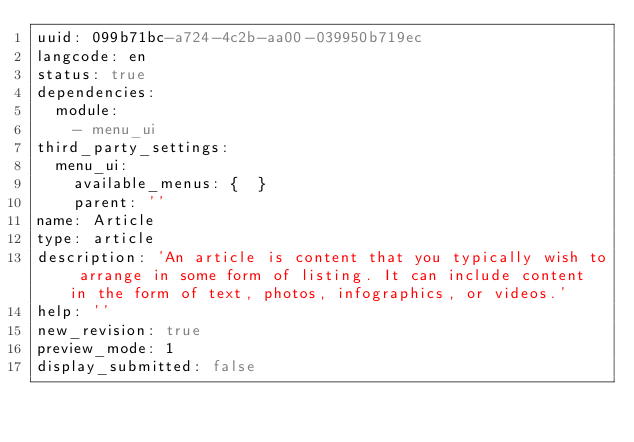Convert code to text. <code><loc_0><loc_0><loc_500><loc_500><_YAML_>uuid: 099b71bc-a724-4c2b-aa00-039950b719ec
langcode: en
status: true
dependencies:
  module:
    - menu_ui
third_party_settings:
  menu_ui:
    available_menus: {  }
    parent: ''
name: Article
type: article
description: 'An article is content that you typically wish to arrange in some form of listing. It can include content in the form of text, photos, infographics, or videos.'
help: ''
new_revision: true
preview_mode: 1
display_submitted: false
</code> 